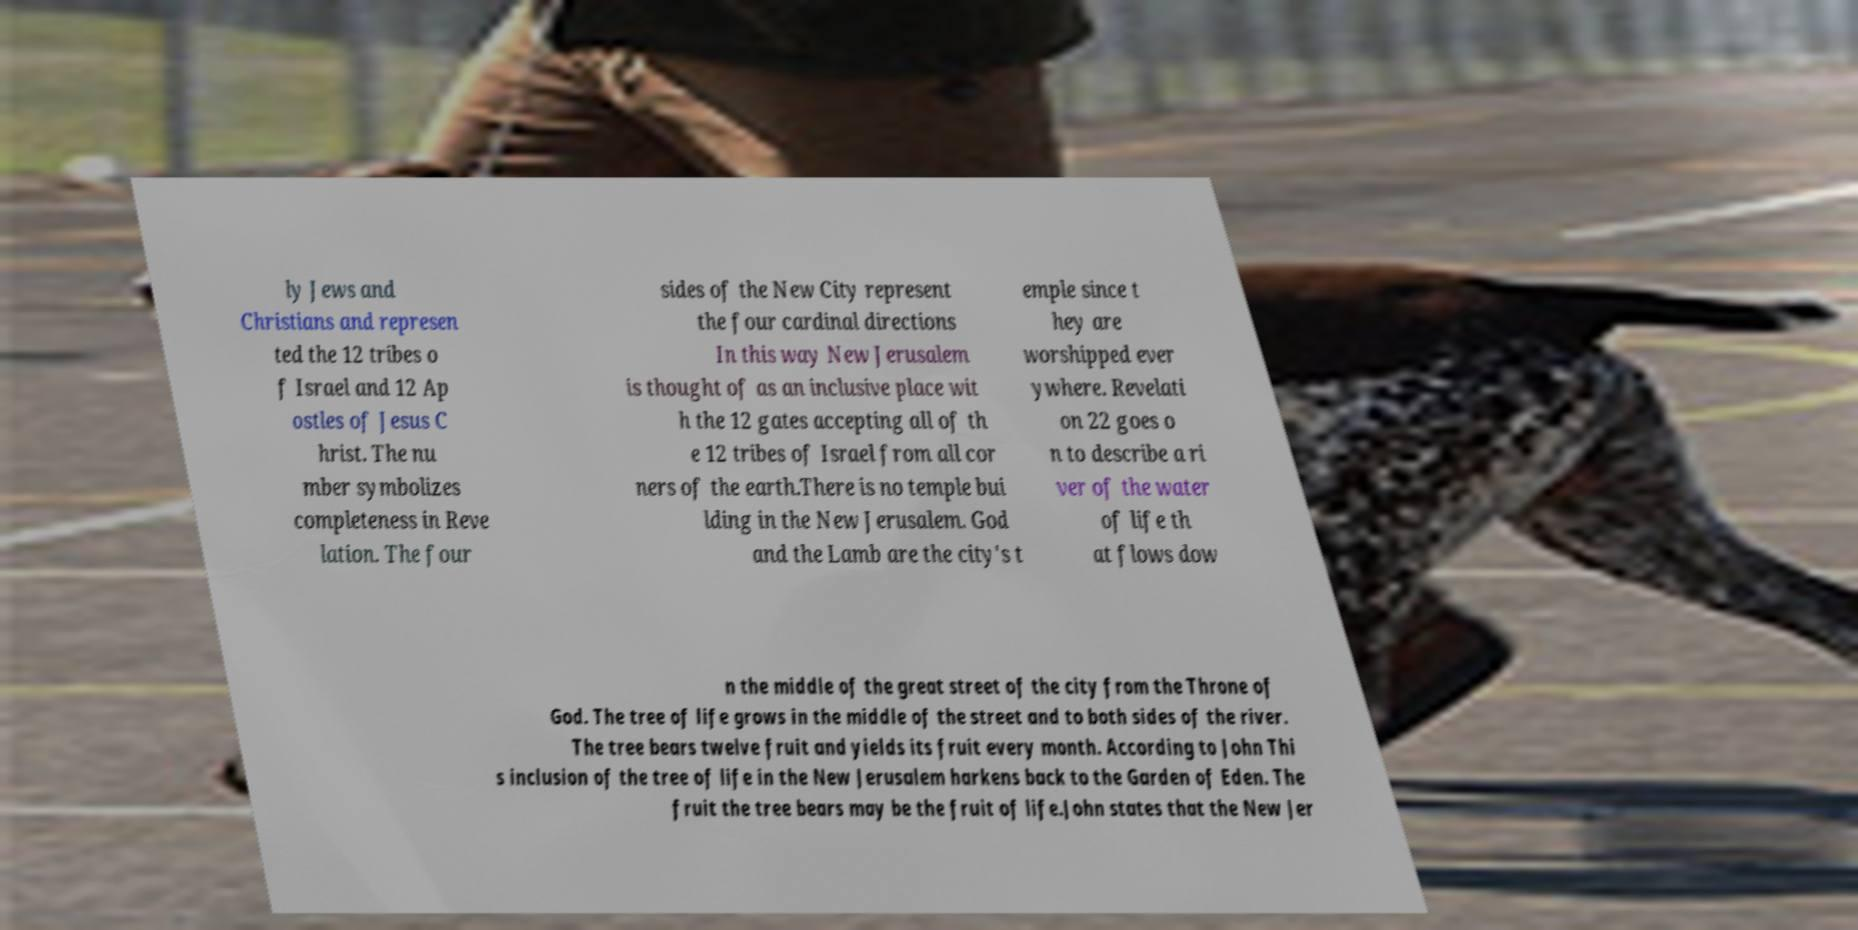Could you extract and type out the text from this image? ly Jews and Christians and represen ted the 12 tribes o f Israel and 12 Ap ostles of Jesus C hrist. The nu mber symbolizes completeness in Reve lation. The four sides of the New City represent the four cardinal directions In this way New Jerusalem is thought of as an inclusive place wit h the 12 gates accepting all of th e 12 tribes of Israel from all cor ners of the earth.There is no temple bui lding in the New Jerusalem. God and the Lamb are the city's t emple since t hey are worshipped ever ywhere. Revelati on 22 goes o n to describe a ri ver of the water of life th at flows dow n the middle of the great street of the city from the Throne of God. The tree of life grows in the middle of the street and to both sides of the river. The tree bears twelve fruit and yields its fruit every month. According to John Thi s inclusion of the tree of life in the New Jerusalem harkens back to the Garden of Eden. The fruit the tree bears may be the fruit of life.John states that the New Jer 